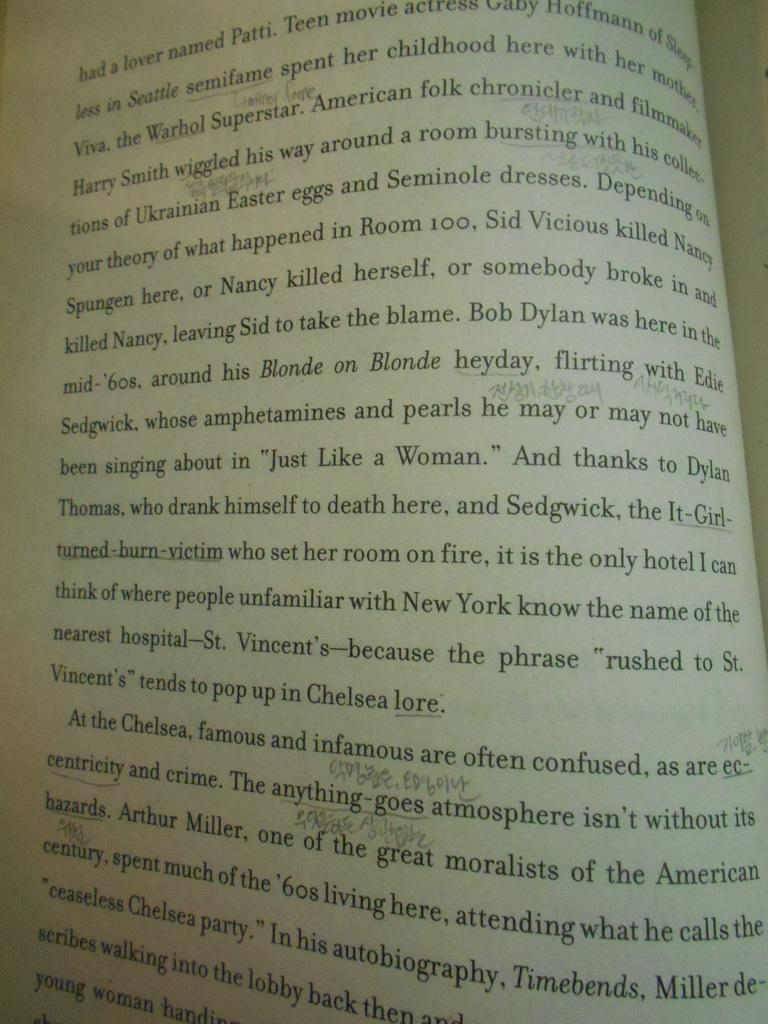Provide a one-sentence caption for the provided image. The book that is open here takes place in New York. 